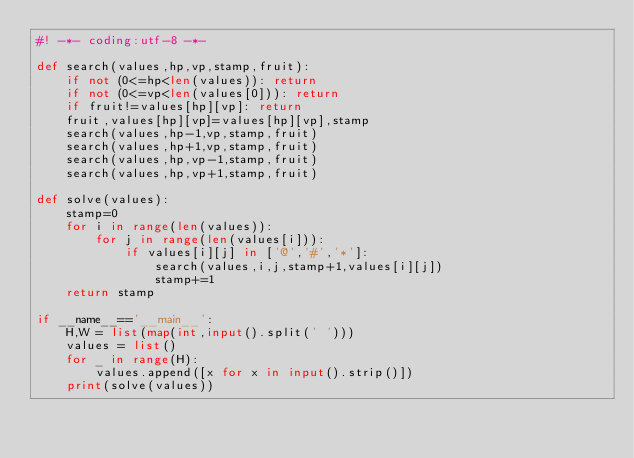<code> <loc_0><loc_0><loc_500><loc_500><_Python_>#! -*- coding:utf-8 -*-

def search(values,hp,vp,stamp,fruit):
    if not (0<=hp<len(values)): return
    if not (0<=vp<len(values[0])): return
    if fruit!=values[hp][vp]: return
    fruit,values[hp][vp]=values[hp][vp],stamp
    search(values,hp-1,vp,stamp,fruit)
    search(values,hp+1,vp,stamp,fruit)
    search(values,hp,vp-1,stamp,fruit)
    search(values,hp,vp+1,stamp,fruit)

def solve(values):
    stamp=0
    for i in range(len(values)):
        for j in range(len(values[i])):
            if values[i][j] in ['@','#','*']:
                search(values,i,j,stamp+1,values[i][j])
                stamp+=1
    return stamp

if __name__=='__main__':
    H,W = list(map(int,input().split(' ')))
    values = list()
    for _ in range(H):
        values.append([x for x in input().strip()])
    print(solve(values))</code> 